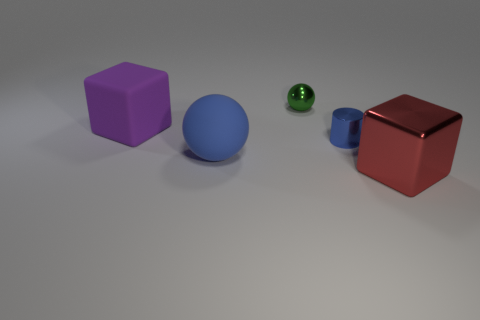There is a large ball that is the same color as the small cylinder; what material is it?
Ensure brevity in your answer.  Rubber. What is the material of the blue sphere that is the same size as the rubber block?
Your response must be concise. Rubber. What number of other things are the same color as the shiny cylinder?
Offer a terse response. 1. How many tiny metal blocks are there?
Your answer should be very brief. 0. How many big blocks are in front of the metallic cylinder and behind the big shiny object?
Ensure brevity in your answer.  0. What material is the small cylinder?
Keep it short and to the point. Metal. Is there a red sphere?
Provide a succinct answer. No. The small metal thing on the left side of the tiny blue metallic thing is what color?
Ensure brevity in your answer.  Green. How many matte cubes are on the right side of the large rubber thing that is on the right side of the big block to the left of the large metal object?
Your answer should be very brief. 0. What material is the large thing that is behind the red metal thing and in front of the purple matte cube?
Offer a very short reply. Rubber. 